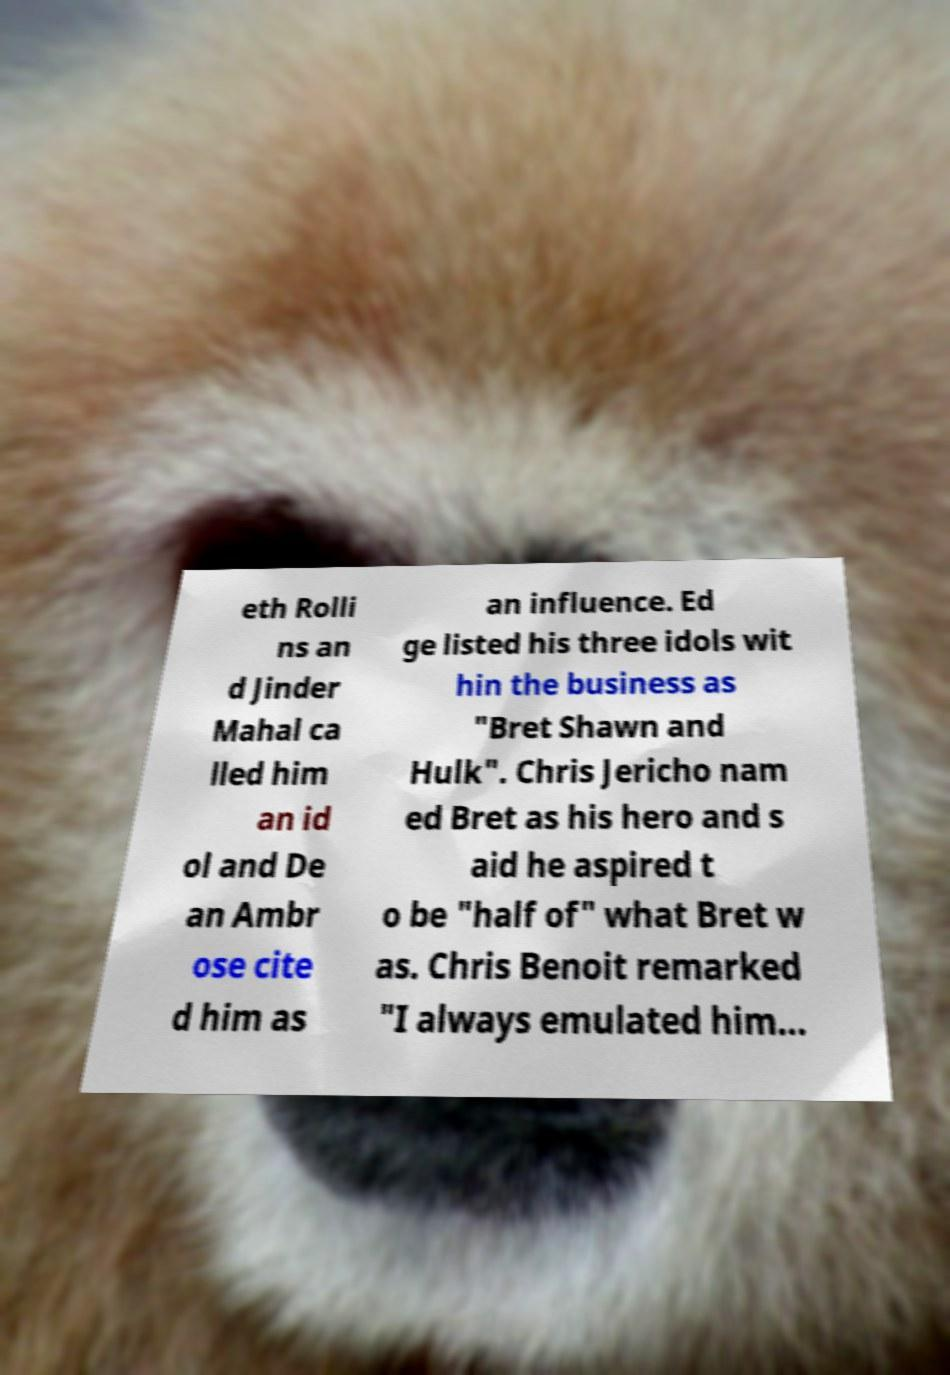I need the written content from this picture converted into text. Can you do that? eth Rolli ns an d Jinder Mahal ca lled him an id ol and De an Ambr ose cite d him as an influence. Ed ge listed his three idols wit hin the business as "Bret Shawn and Hulk". Chris Jericho nam ed Bret as his hero and s aid he aspired t o be "half of" what Bret w as. Chris Benoit remarked "I always emulated him... 